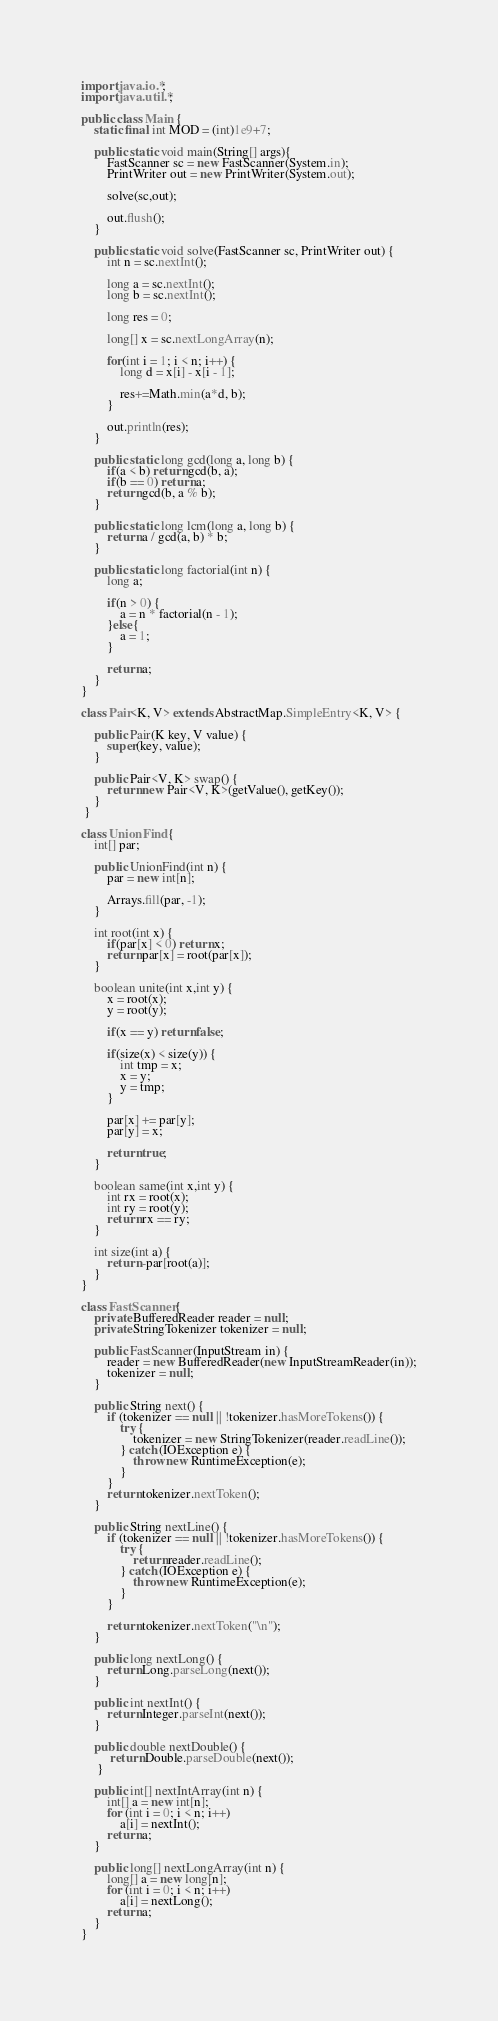<code> <loc_0><loc_0><loc_500><loc_500><_Java_>import java.io.*;
import java.util.*;

public class Main {
	static final int MOD = (int)1e9+7;

	public static void main(String[] args){
		FastScanner sc = new FastScanner(System.in);
		PrintWriter out = new PrintWriter(System.out);

		solve(sc,out);

		out.flush();
	}

	public static void solve(FastScanner sc, PrintWriter out) {
		int n = sc.nextInt();
		
		long a = sc.nextInt();
		long b = sc.nextInt();
		
		long res = 0;

		long[] x = sc.nextLongArray(n);
		
		for(int i = 1; i < n; i++) {
			long d = x[i] - x[i - 1];
			
			res+=Math.min(a*d, b);
		}
		
		out.println(res);
	}

	public static long gcd(long a, long b) {
		if(a < b) return gcd(b, a);
		if(b == 0) return a;
		return gcd(b, a % b);
	}

	public static long lcm(long a, long b) {
		return a / gcd(a, b) * b;
	}

	public static long factorial(int n) {
		long a;

		if(n > 0) {
			a = n * factorial(n - 1);
		}else{
			a = 1;
		}

		return a;
	}
}

class Pair<K, V> extends AbstractMap.SimpleEntry<K, V> {

    public Pair(K key, V value) {
        super(key, value);
    }

    public Pair<V, K> swap() {
    	return new Pair<V, K>(getValue(), getKey());
    }
 }

class UnionFind {
	int[] par;

	public UnionFind(int n) {
		par = new int[n];

		Arrays.fill(par, -1);
	}

	int root(int x) {
		if(par[x] < 0) return x;
		return par[x] = root(par[x]);
	}

	boolean unite(int x,int y) {
		x = root(x);
		y = root(y);

		if(x == y) return false;

		if(size(x) < size(y)) {
			int tmp = x;
			x = y;
			y = tmp;
		}

		par[x] += par[y];
		par[y] = x;

		return true;
	}

	boolean same(int x,int y) {
		int rx = root(x);
		int ry = root(y);
		return rx == ry;
	}

	int size(int a) {
		return -par[root(a)];
	}
}

class FastScanner {
    private BufferedReader reader = null;
    private StringTokenizer tokenizer = null;

    public FastScanner(InputStream in) {
        reader = new BufferedReader(new InputStreamReader(in));
        tokenizer = null;
    }

    public String next() {
        if (tokenizer == null || !tokenizer.hasMoreTokens()) {
            try {
                tokenizer = new StringTokenizer(reader.readLine());
            } catch (IOException e) {
                throw new RuntimeException(e);
            }
        }
        return tokenizer.nextToken();
    }

    public String nextLine() {
        if (tokenizer == null || !tokenizer.hasMoreTokens()) {
            try {
                return reader.readLine();
            } catch (IOException e) {
                throw new RuntimeException(e);
            }
        }

        return tokenizer.nextToken("\n");
    }

    public long nextLong() {
        return Long.parseLong(next());
    }

    public int nextInt() {
        return Integer.parseInt(next());
    }

    public double nextDouble() {
         return Double.parseDouble(next());
     }

    public int[] nextIntArray(int n) {
        int[] a = new int[n];
        for (int i = 0; i < n; i++)
            a[i] = nextInt();
        return a;
    }

    public long[] nextLongArray(int n) {
        long[] a = new long[n];
        for (int i = 0; i < n; i++)
            a[i] = nextLong();
        return a;
    }
}</code> 